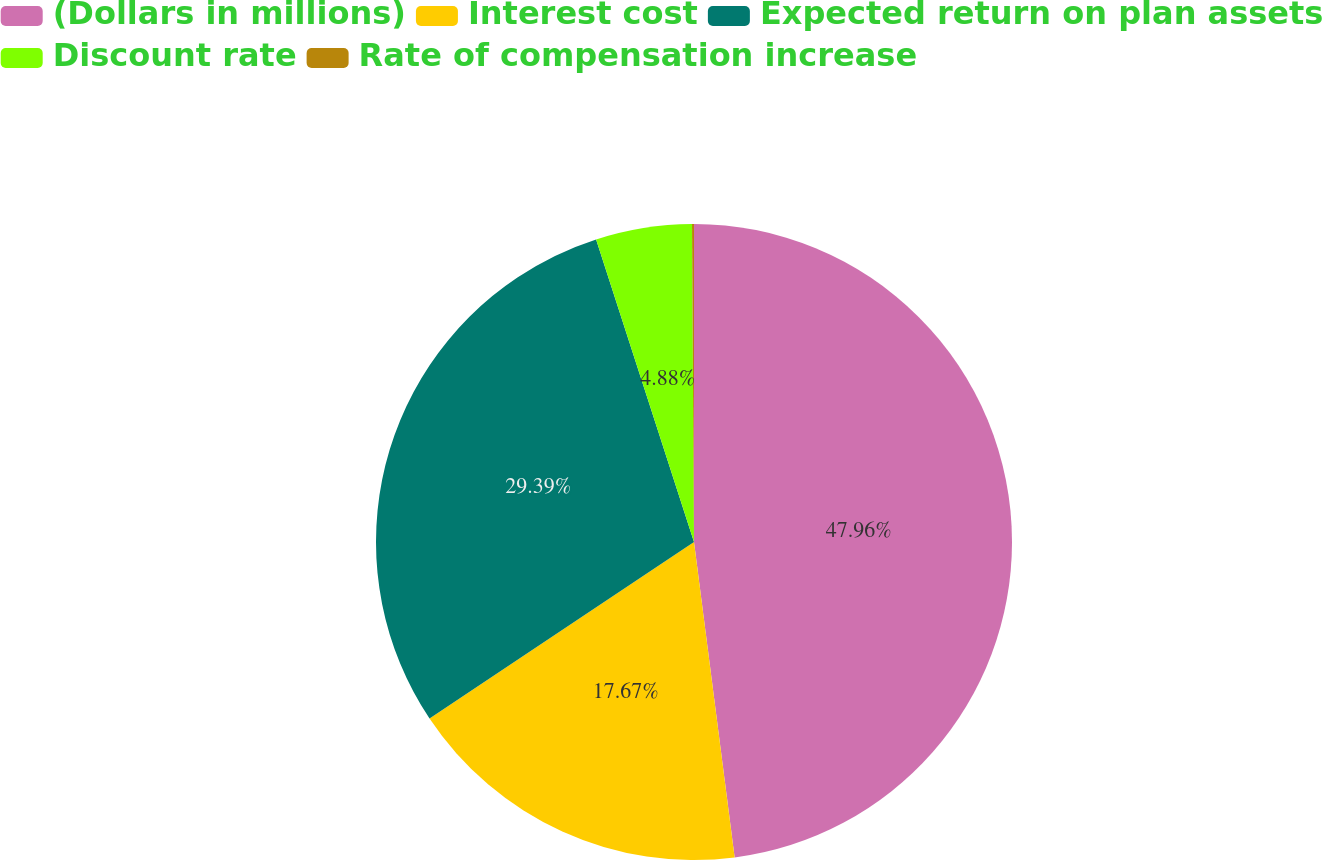<chart> <loc_0><loc_0><loc_500><loc_500><pie_chart><fcel>(Dollars in millions)<fcel>Interest cost<fcel>Expected return on plan assets<fcel>Discount rate<fcel>Rate of compensation increase<nl><fcel>47.96%<fcel>17.67%<fcel>29.39%<fcel>4.88%<fcel>0.1%<nl></chart> 